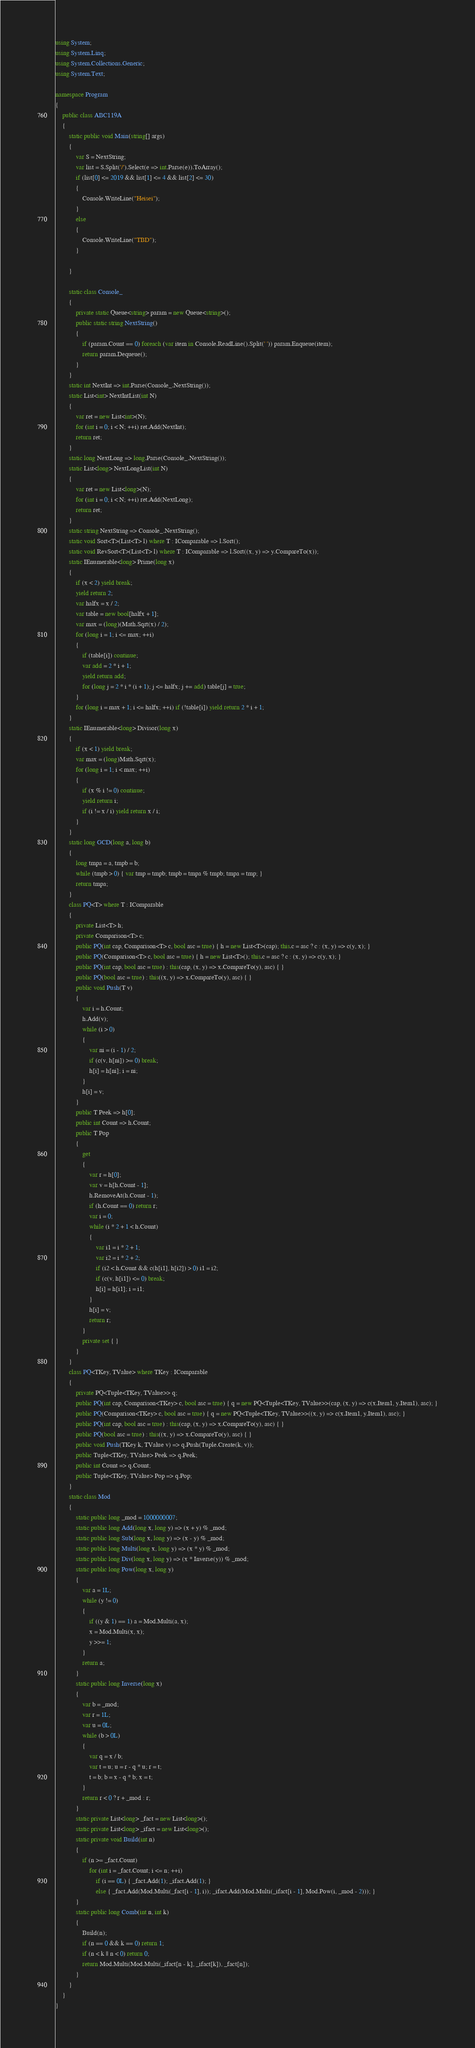Convert code to text. <code><loc_0><loc_0><loc_500><loc_500><_C#_>using System;
using System.Linq;
using System.Collections.Generic;
using System.Text;

namespace Program
{
    public class ABC119A
    {
        static public void Main(string[] args)
        {
            var S = NextString;
            var list = S.Split('/').Select(e => int.Parse(e)).ToArray();
            if (list[0] <= 2019 && list[1] <= 4 && list[2] <= 30)
            {
                Console.WriteLine("Heisei");
            }
            else
            {
                Console.WriteLine("TBD");
            }

        }

        static class Console_
        {
            private static Queue<string> param = new Queue<string>();
            public static string NextString()
            {
                if (param.Count == 0) foreach (var item in Console.ReadLine().Split(' ')) param.Enqueue(item);
                return param.Dequeue();
            }
        }
        static int NextInt => int.Parse(Console_.NextString());
        static List<int> NextIntList(int N)
        {
            var ret = new List<int>(N);
            for (int i = 0; i < N; ++i) ret.Add(NextInt);
            return ret;
        }
        static long NextLong => long.Parse(Console_.NextString());
        static List<long> NextLongList(int N)
        {
            var ret = new List<long>(N);
            for (int i = 0; i < N; ++i) ret.Add(NextLong);
            return ret;
        }
        static string NextString => Console_.NextString();
        static void Sort<T>(List<T> l) where T : IComparable => l.Sort();
        static void RevSort<T>(List<T> l) where T : IComparable => l.Sort((x, y) => y.CompareTo(x));
        static IEnumerable<long> Prime(long x)
        {
            if (x < 2) yield break;
            yield return 2;
            var halfx = x / 2;
            var table = new bool[halfx + 1];
            var max = (long)(Math.Sqrt(x) / 2);
            for (long i = 1; i <= max; ++i)
            {
                if (table[i]) continue;
                var add = 2 * i + 1;
                yield return add;
                for (long j = 2 * i * (i + 1); j <= halfx; j += add) table[j] = true;
            }
            for (long i = max + 1; i <= halfx; ++i) if (!table[i]) yield return 2 * i + 1;
        }
        static IEnumerable<long> Divisor(long x)
        {
            if (x < 1) yield break;
            var max = (long)Math.Sqrt(x);
            for (long i = 1; i < max; ++i)
            {
                if (x % i != 0) continue;
                yield return i;
                if (i != x / i) yield return x / i;
            }
        }
        static long GCD(long a, long b)
        {
            long tmpa = a, tmpb = b;
            while (tmpb > 0) { var tmp = tmpb; tmpb = tmpa % tmpb; tmpa = tmp; }
            return tmpa;
        }
        class PQ<T> where T : IComparable
        {
            private List<T> h;
            private Comparison<T> c;
            public PQ(int cap, Comparison<T> c, bool asc = true) { h = new List<T>(cap); this.c = asc ? c : (x, y) => c(y, x); }
            public PQ(Comparison<T> c, bool asc = true) { h = new List<T>(); this.c = asc ? c : (x, y) => c(y, x); }
            public PQ(int cap, bool asc = true) : this(cap, (x, y) => x.CompareTo(y), asc) { }
            public PQ(bool asc = true) : this((x, y) => x.CompareTo(y), asc) { }
            public void Push(T v)
            {
                var i = h.Count;
                h.Add(v);
                while (i > 0)
                {
                    var ni = (i - 1) / 2;
                    if (c(v, h[ni]) >= 0) break;
                    h[i] = h[ni]; i = ni;
                }
                h[i] = v;
            }
            public T Peek => h[0];
            public int Count => h.Count;
            public T Pop
            {
                get
                {
                    var r = h[0];
                    var v = h[h.Count - 1];
                    h.RemoveAt(h.Count - 1);
                    if (h.Count == 0) return r;
                    var i = 0;
                    while (i * 2 + 1 < h.Count)
                    {
                        var i1 = i * 2 + 1;
                        var i2 = i * 2 + 2;
                        if (i2 < h.Count && c(h[i1], h[i2]) > 0) i1 = i2;
                        if (c(v, h[i1]) <= 0) break;
                        h[i] = h[i1]; i = i1;
                    }
                    h[i] = v;
                    return r;
                }
                private set { }
            }
        }
        class PQ<TKey, TValue> where TKey : IComparable
        {
            private PQ<Tuple<TKey, TValue>> q;
            public PQ(int cap, Comparison<TKey> c, bool asc = true) { q = new PQ<Tuple<TKey, TValue>>(cap, (x, y) => c(x.Item1, y.Item1), asc); }
            public PQ(Comparison<TKey> c, bool asc = true) { q = new PQ<Tuple<TKey, TValue>>((x, y) => c(x.Item1, y.Item1), asc); }
            public PQ(int cap, bool asc = true) : this(cap, (x, y) => x.CompareTo(y), asc) { }
            public PQ(bool asc = true) : this((x, y) => x.CompareTo(y), asc) { }
            public void Push(TKey k, TValue v) => q.Push(Tuple.Create(k, v));
            public Tuple<TKey, TValue> Peek => q.Peek;
            public int Count => q.Count;
            public Tuple<TKey, TValue> Pop => q.Pop;
        }
        static class Mod
        {
            static public long _mod = 1000000007;
            static public long Add(long x, long y) => (x + y) % _mod;
            static public long Sub(long x, long y) => (x - y) % _mod;
            static public long Multi(long x, long y) => (x * y) % _mod;
            static public long Div(long x, long y) => (x * Inverse(y)) % _mod;
            static public long Pow(long x, long y)
            {
                var a = 1L;
                while (y != 0)
                {
                    if ((y & 1) == 1) a = Mod.Multi(a, x);
                    x = Mod.Multi(x, x);
                    y >>= 1;
                }
                return a;
            }
            static public long Inverse(long x)
            {
                var b = _mod;
                var r = 1L;
                var u = 0L;
                while (b > 0L)
                {
                    var q = x / b;
                    var t = u; u = r - q * u; r = t;
                    t = b; b = x - q * b; x = t;
                }
                return r < 0 ? r + _mod : r;
            }
            static private List<long> _fact = new List<long>();
            static private List<long> _ifact = new List<long>();
            static private void Build(int n)
            {
                if (n >= _fact.Count)
                    for (int i = _fact.Count; i <= n; ++i)
                        if (i == 0L) { _fact.Add(1); _ifact.Add(1); }
                        else { _fact.Add(Mod.Multi(_fact[i - 1], i)); _ifact.Add(Mod.Multi(_ifact[i - 1], Mod.Pow(i, _mod - 2))); }
            }
            static public long Comb(int n, int k)
            {
                Build(n);
                if (n == 0 && k == 0) return 1;
                if (n < k || n < 0) return 0;
                return Mod.Multi(Mod.Multi(_ifact[n - k], _ifact[k]), _fact[n]);
            }
        }
    }
}
</code> 